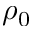<formula> <loc_0><loc_0><loc_500><loc_500>\rho _ { 0 }</formula> 